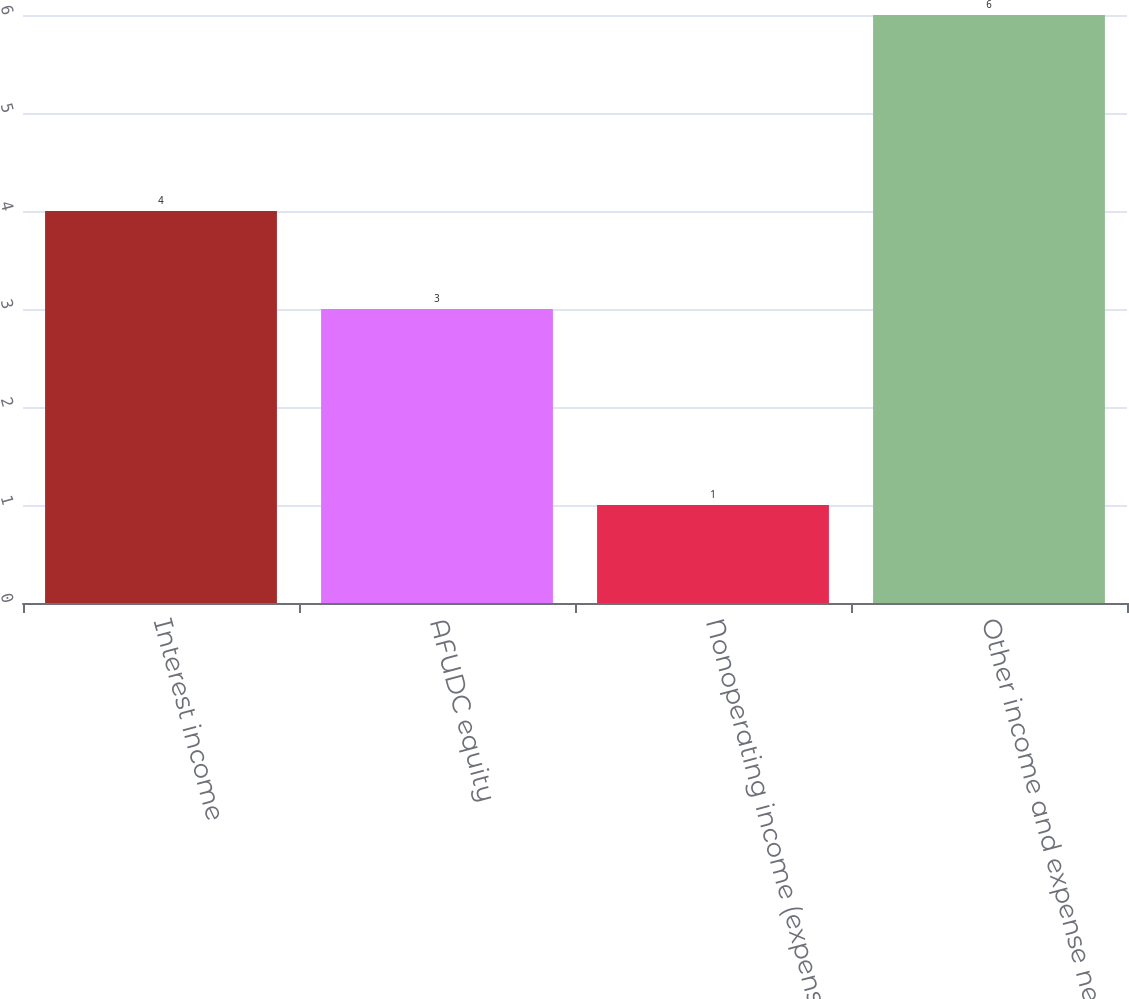Convert chart. <chart><loc_0><loc_0><loc_500><loc_500><bar_chart><fcel>Interest income<fcel>AFUDC equity<fcel>Nonoperating income (expense)<fcel>Other income and expense net<nl><fcel>4<fcel>3<fcel>1<fcel>6<nl></chart> 